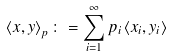<formula> <loc_0><loc_0><loc_500><loc_500>\left \langle x , y \right \rangle _ { p } \colon = \sum _ { i = 1 } ^ { \infty } p _ { i } \left \langle x _ { i } , y _ { i } \right \rangle</formula> 